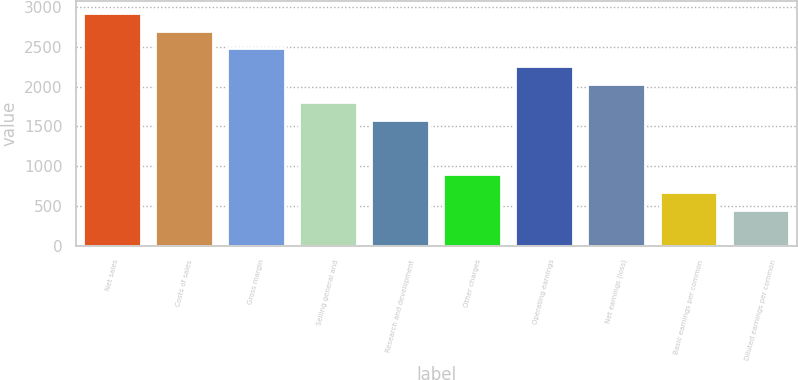Convert chart. <chart><loc_0><loc_0><loc_500><loc_500><bar_chart><fcel>Net sales<fcel>Costs of sales<fcel>Gross margin<fcel>Selling general and<fcel>Research and development<fcel>Other charges<fcel>Operating earnings<fcel>Net earnings (loss)<fcel>Basic earnings per common<fcel>Diluted earnings per common<nl><fcel>2930.07<fcel>2704.72<fcel>2479.37<fcel>1803.32<fcel>1577.97<fcel>901.92<fcel>2254.02<fcel>2028.67<fcel>676.57<fcel>451.22<nl></chart> 